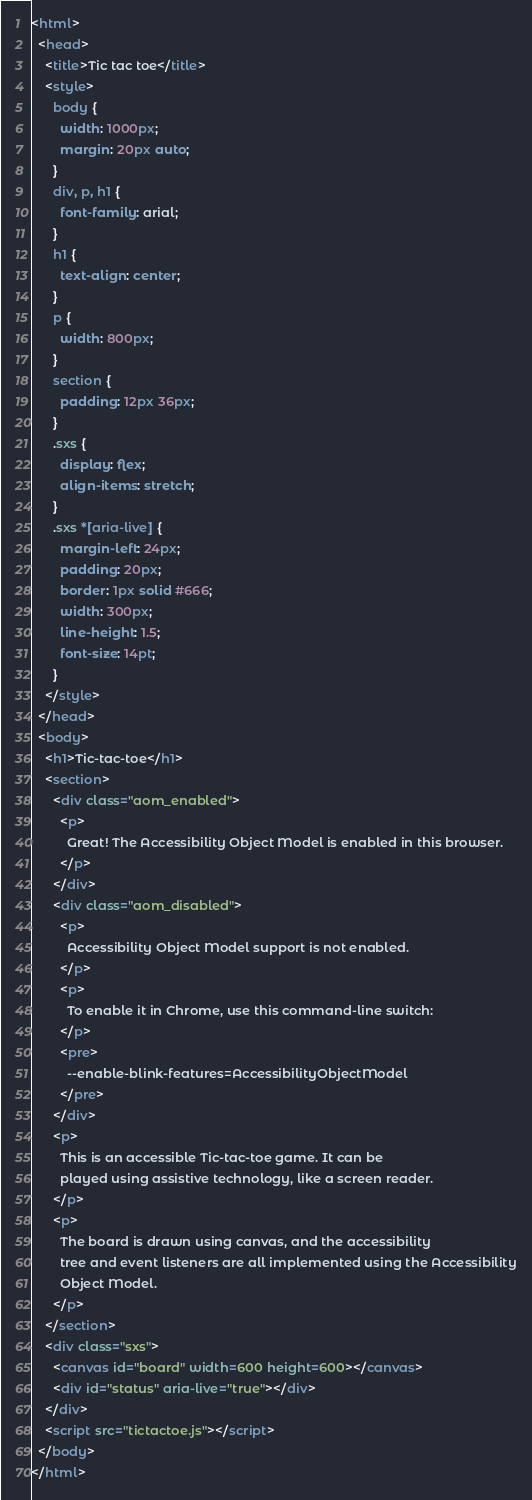Convert code to text. <code><loc_0><loc_0><loc_500><loc_500><_HTML_><html>
  <head>
    <title>Tic tac toe</title>
    <style>
      body {
        width: 1000px;
        margin: 20px auto;
      }
      div, p, h1 {
        font-family: arial;
      }
      h1 {
        text-align: center;
      }
      p {
        width: 800px;
      }
      section {
        padding: 12px 36px;
      }
      .sxs {
        display: flex;
        align-items: stretch;
      }
      .sxs *[aria-live] {
        margin-left: 24px;
        padding: 20px;
        border: 1px solid #666;
        width: 300px;
        line-height: 1.5;
        font-size: 14pt;
      }
    </style>
  </head>
  <body>
    <h1>Tic-tac-toe</h1>
    <section>
      <div class="aom_enabled">
        <p>
          Great! The Accessibility Object Model is enabled in this browser.
        </p>
      </div>
      <div class="aom_disabled">
        <p>
          Accessibility Object Model support is not enabled.
        </p>
        <p>
          To enable it in Chrome, use this command-line switch:
        </p>
        <pre>
          --enable-blink-features=AccessibilityObjectModel
        </pre>
      </div>
      <p>
        This is an accessible Tic-tac-toe game. It can be
        played using assistive technology, like a screen reader.
      </p>
      <p>
        The board is drawn using canvas, and the accessibility
        tree and event listeners are all implemented using the Accessibility
        Object Model.
      </p>
    </section>
    <div class="sxs">
      <canvas id="board" width=600 height=600></canvas>
      <div id="status" aria-live="true"></div>
    </div>
    <script src="tictactoe.js"></script>
  </body>
</html>
</code> 